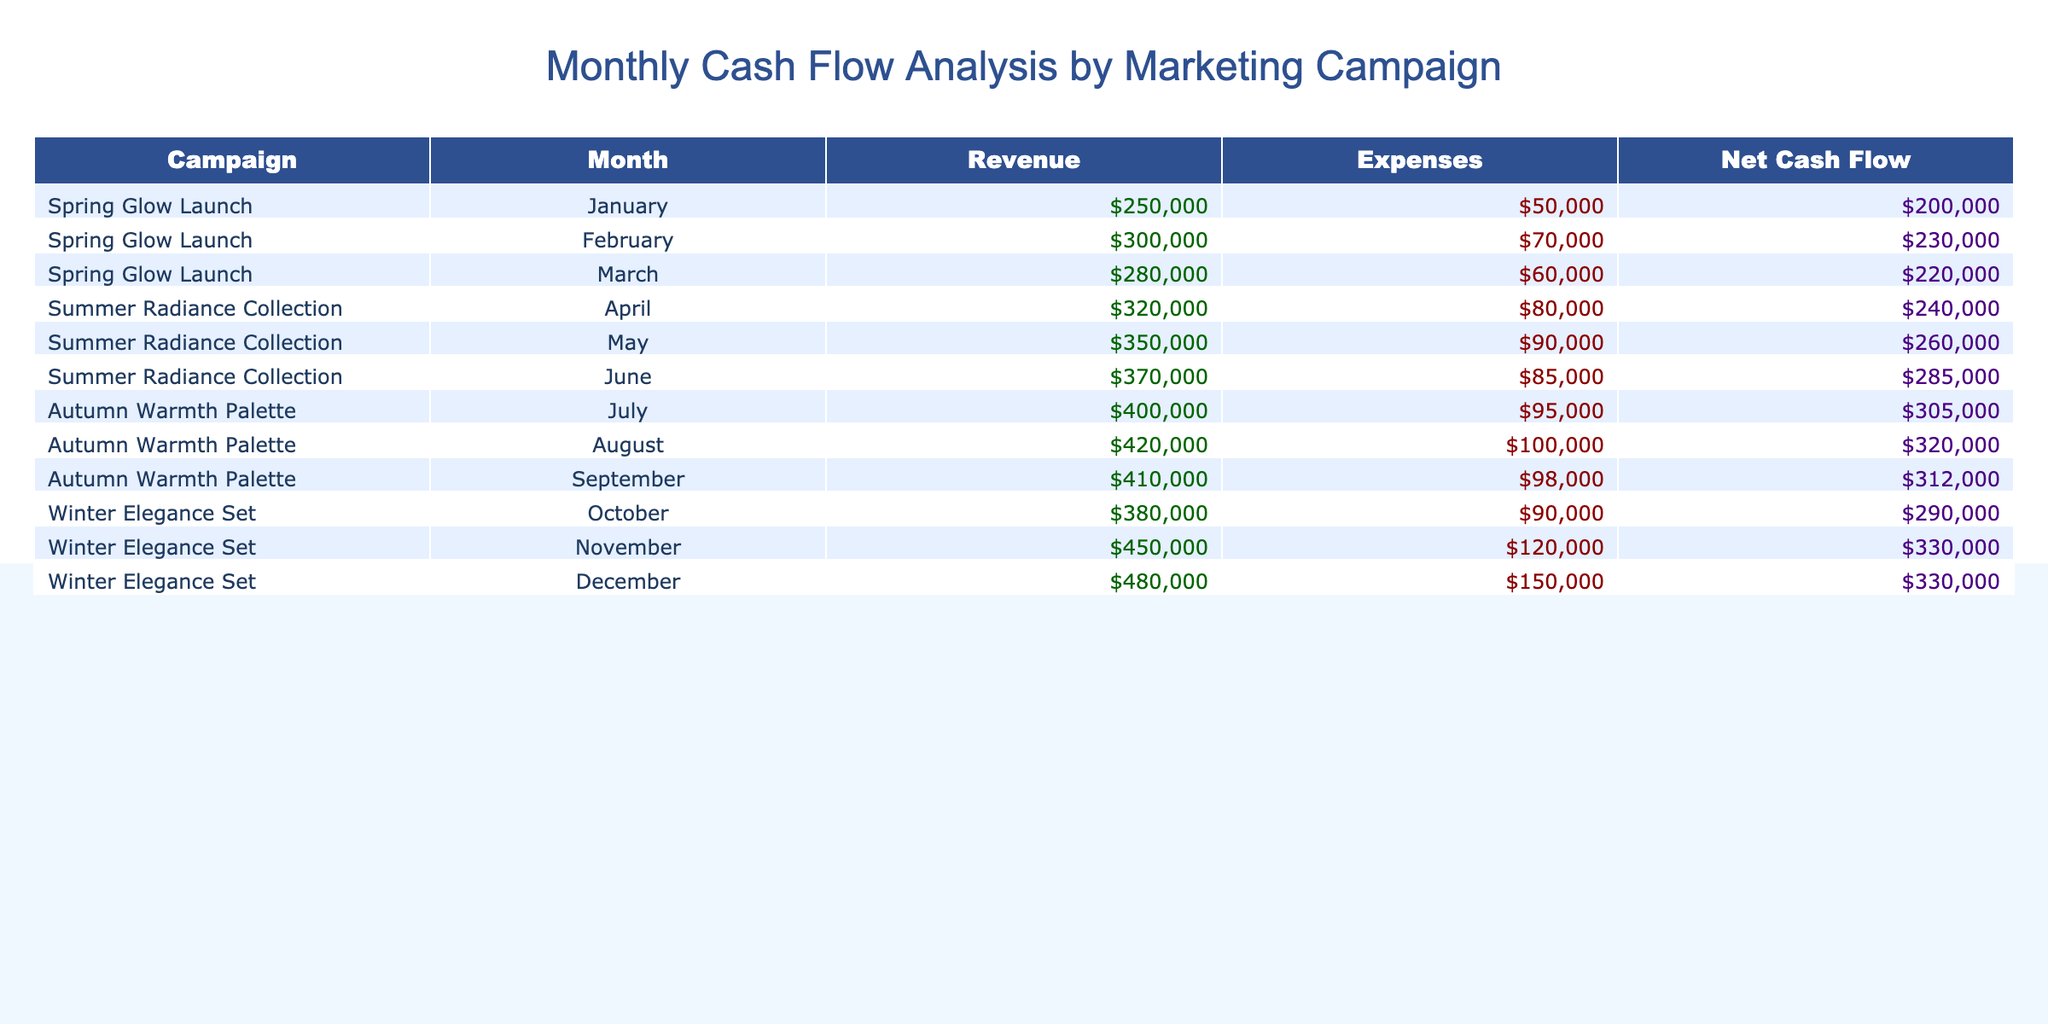What was the total revenue generated by the "Winter Elegance Set" campaign? The total revenue from the "Winter Elegance Set" campaign includes revenue from October, November, and December: 380000 + 450000 + 480000 = 1310000.
Answer: 1310000 What is the average expenses for the "Summer Radiance Collection" campaign? The total expenses for the "Summer Radiance Collection" are 80000 + 90000 + 85000 = 255000. There are 3 months, so the average is 255000 / 3 = 85000.
Answer: 85000 Did the "Autumn Warmth Palette" campaign have a net cash flow greater than 300000 in any month? The net cash flows for the "Autumn Warmth Palette" are 305000, 320000, and 312000 for July, August, and September respectively. Each of these is greater than 300000.
Answer: Yes What was the month with the highest net cash flow, and what was the amount? By reviewing the net cash flow column, the highest net cash flow is for the "Winter Elegance Set" in November, which is 330000.
Answer: November, 330000 What is the difference in net cash flow between the "Spring Glow Launch" campaign in February and that in March? The net cash flows for February and March in the "Spring Glow Launch" campaign are 230000 and 220000, respectively. The difference is 230000 - 220000 = 10000.
Answer: 10000 Was the total revenue generated by the "Summer Radiance Collection" campaign lower than that of the "Spring Glow Launch"? The total revenue for "Summer Radiance Collection" is 320000 + 350000 + 370000 = 1040000, while for "Spring Glow Launch," it is 250000 + 300000 + 280000 = 830000. Since 1040000 is greater than 830000, the statement is false.
Answer: No What is the cumulative net cash flow for all campaigns from January to December? To calculate the cumulative net cash flow, we sum all net cash flows: 200000 + 230000 + 220000 + 240000 + 260000 + 285000 + 305000 + 320000 + 312000 + 290000 + 330000 + 330000 = 3025000.
Answer: 3025000 Which marketing campaign had the largest increase in revenue month-over-month? Reviewing the revenue data, the "Winter Elegance Set" campaign shows an increase from October (380000) to November (450000), which is an increase of 70000. Other campaigns did not exceed this increase month-over-month.
Answer: Winter Elegance Set What is the ratio of expenses to revenue for the "Spring Glow Launch" campaign in March? For March, expenses are 60000, and revenue is 280000. The ratio is 60000 / 280000 = 0.214, approximately 1:4.67.
Answer: 1:4.67 